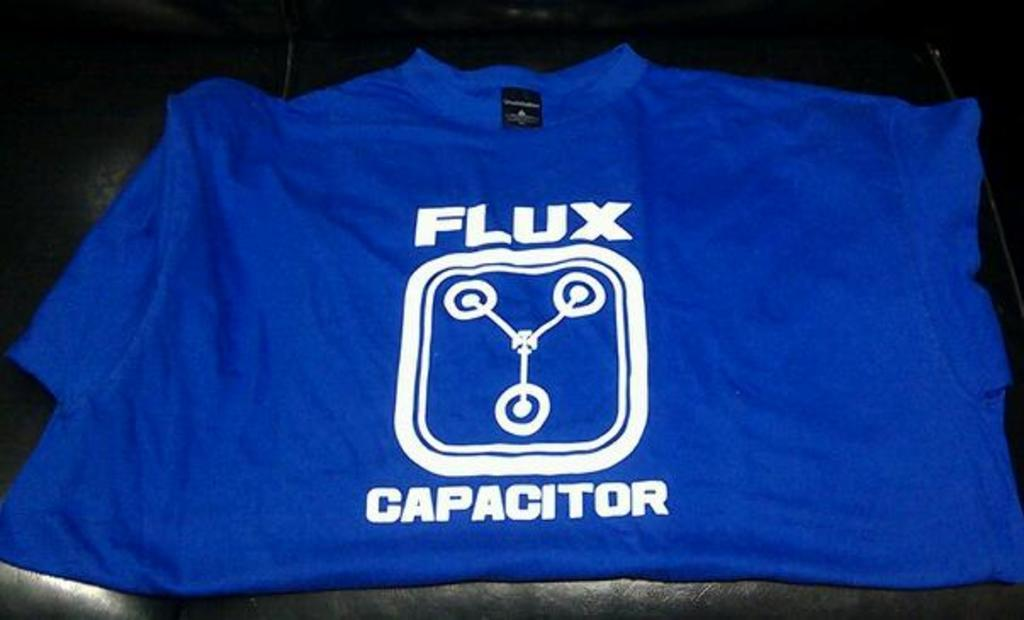<image>
Render a clear and concise summary of the photo. A blue shirt that says, "Flux Capacitor" in white writing is folded. 